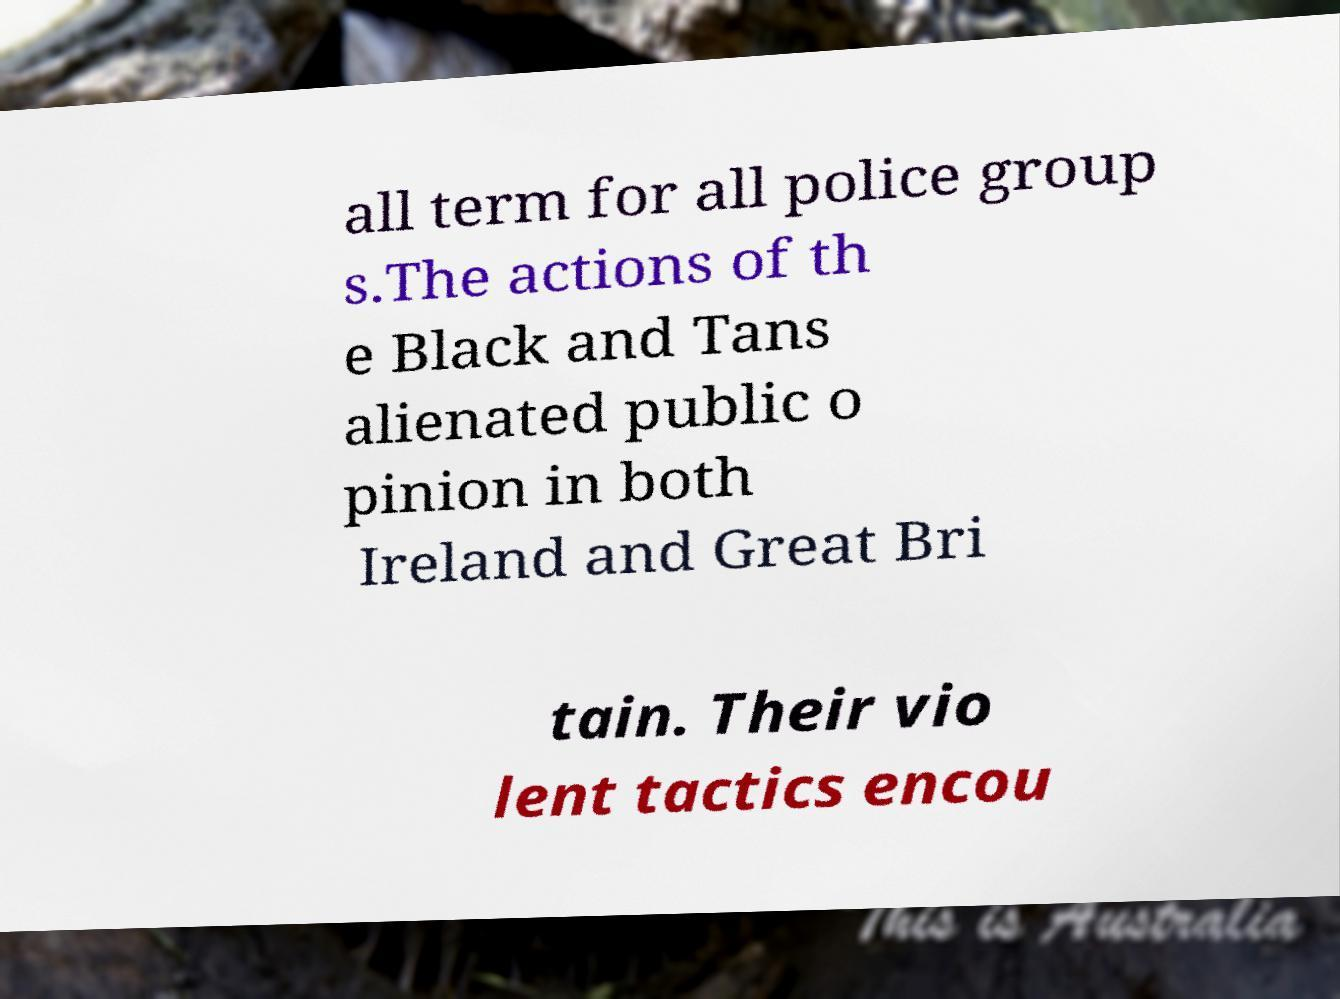Can you accurately transcribe the text from the provided image for me? all term for all police group s.The actions of th e Black and Tans alienated public o pinion in both Ireland and Great Bri tain. Their vio lent tactics encou 